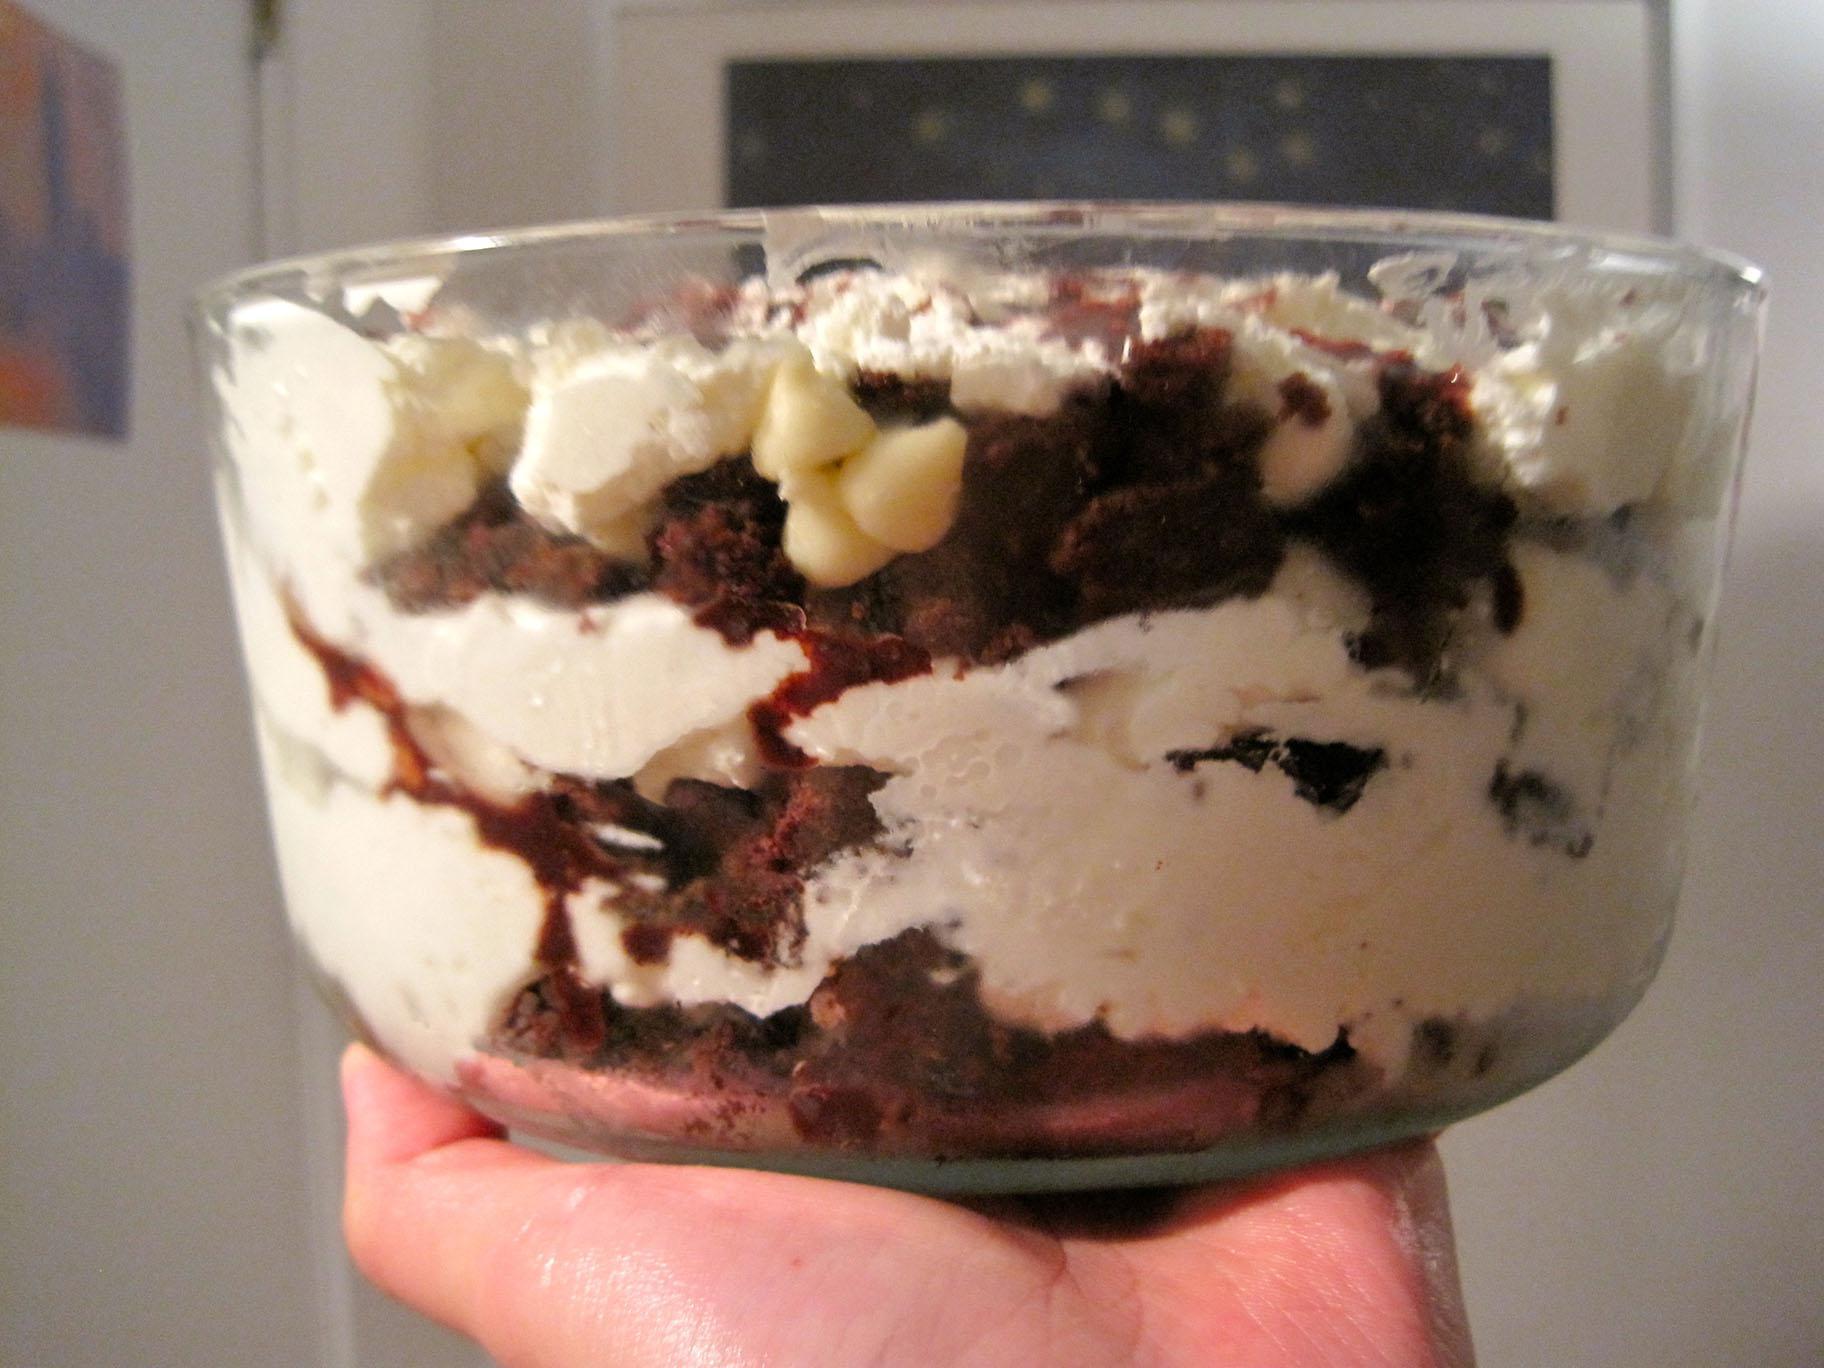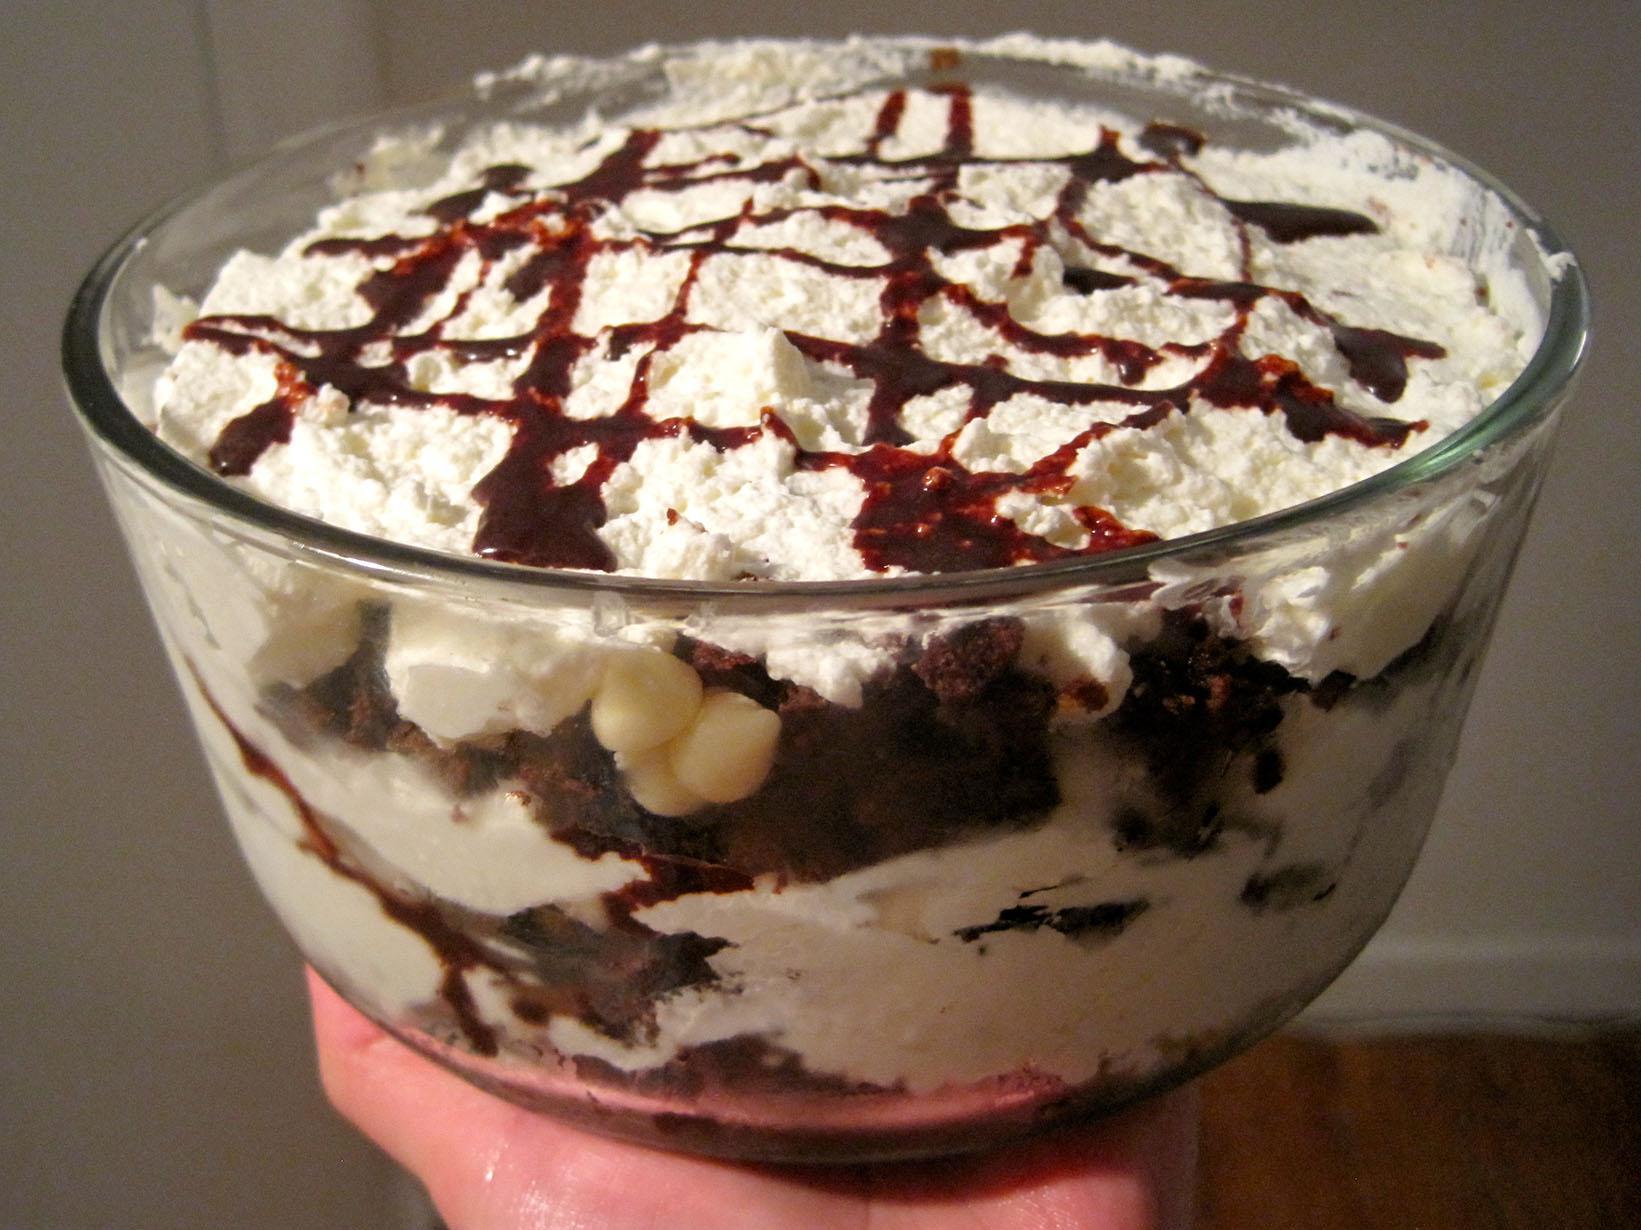The first image is the image on the left, the second image is the image on the right. For the images displayed, is the sentence "1 of the images has 1 candle in the background." factually correct? Answer yes or no. No. 